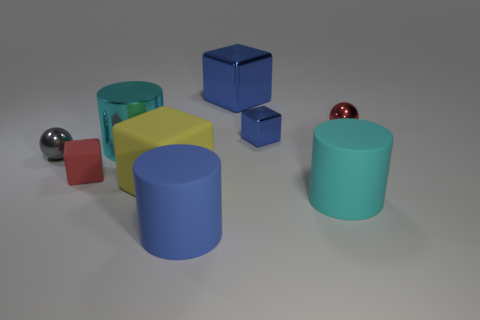Subtract all yellow cubes. How many cubes are left? 3 Subtract 2 cylinders. How many cylinders are left? 1 Subtract all red balls. How many balls are left? 1 Subtract all gray spheres. How many red blocks are left? 1 Subtract all big yellow objects. Subtract all metallic cylinders. How many objects are left? 7 Add 5 gray things. How many gray things are left? 6 Add 4 large blocks. How many large blocks exist? 6 Subtract 0 cyan balls. How many objects are left? 9 Subtract all blocks. How many objects are left? 5 Subtract all red cubes. Subtract all green cylinders. How many cubes are left? 3 